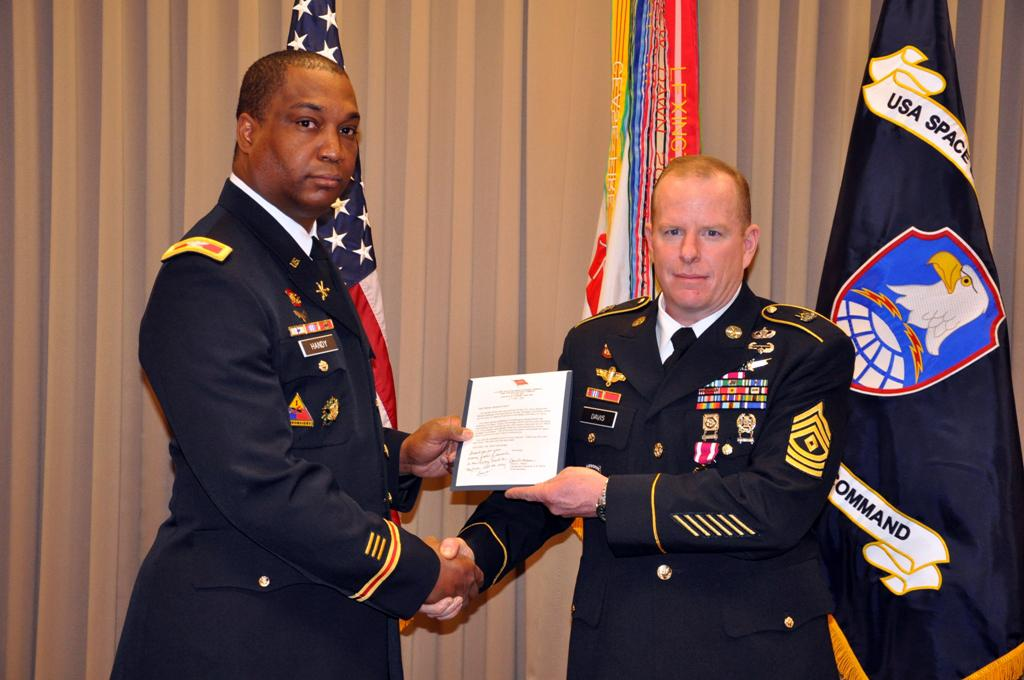<image>
Present a compact description of the photo's key features. Two men in military uniforms hold a plaque in front of a USA Space Command flag. 